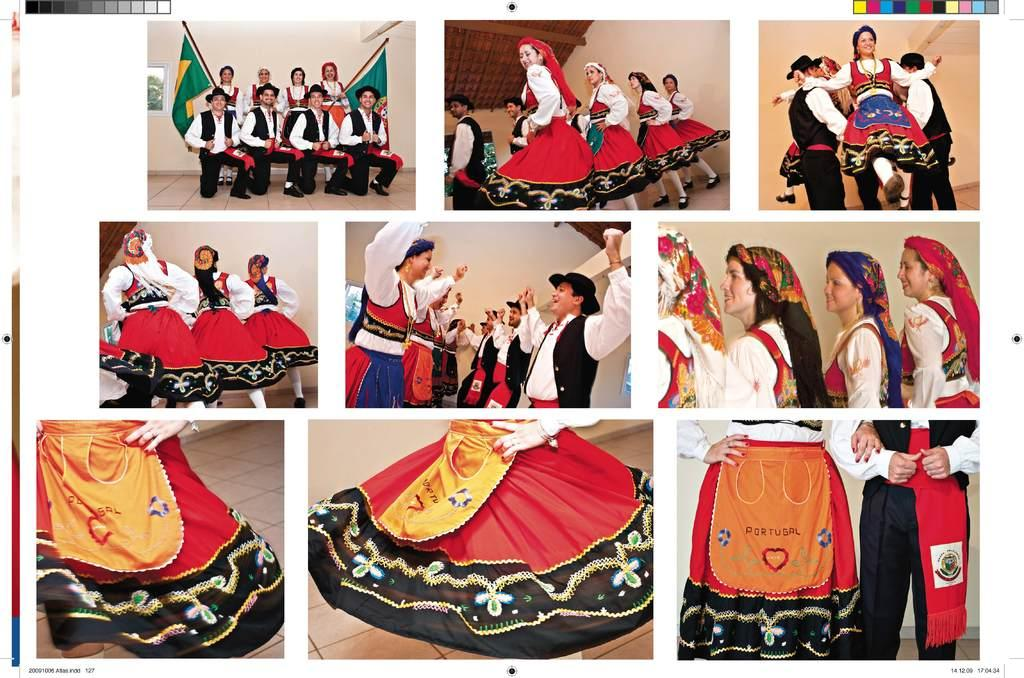What is placed on the white platform in the image? There are photos on the white platform in the image. What do the photos depict? The photos depict people dancing and flags. What specific activity are the people engaged in, as shown in the photos? The people in the photos are dancing. What type of swing can be seen in the image? There is no swing present in the image; it features photos of people dancing and flags. How is the thread used in the image? There is no thread present in the image. 